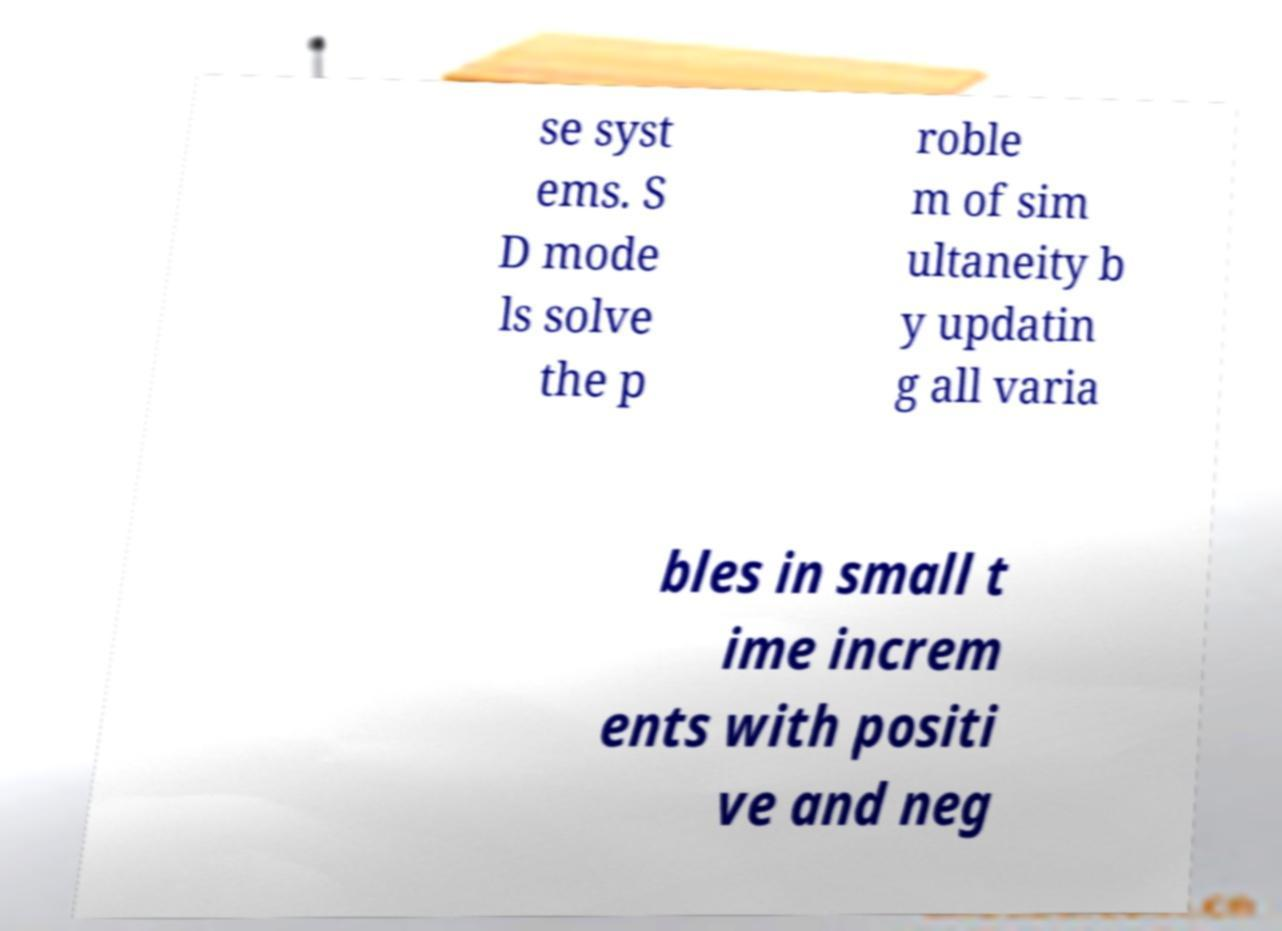Could you extract and type out the text from this image? se syst ems. S D mode ls solve the p roble m of sim ultaneity b y updatin g all varia bles in small t ime increm ents with positi ve and neg 